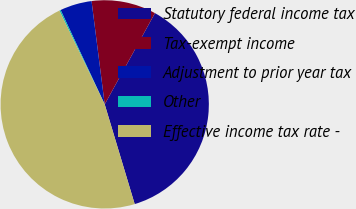Convert chart. <chart><loc_0><loc_0><loc_500><loc_500><pie_chart><fcel>Statutory federal income tax<fcel>Tax-exempt income<fcel>Adjustment to prior year tax<fcel>Other<fcel>Effective income tax rate -<nl><fcel>37.34%<fcel>10.03%<fcel>4.94%<fcel>0.21%<fcel>47.48%<nl></chart> 